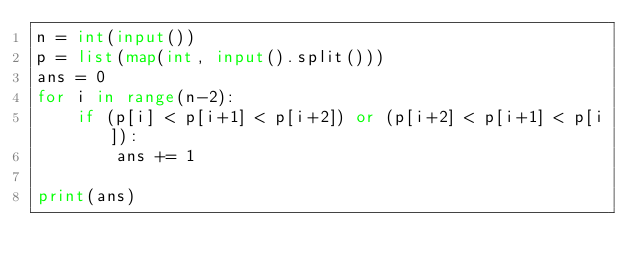<code> <loc_0><loc_0><loc_500><loc_500><_Python_>n = int(input())
p = list(map(int, input().split()))
ans = 0
for i in range(n-2):
    if (p[i] < p[i+1] < p[i+2]) or (p[i+2] < p[i+1] < p[i]):
        ans += 1

print(ans)
</code> 